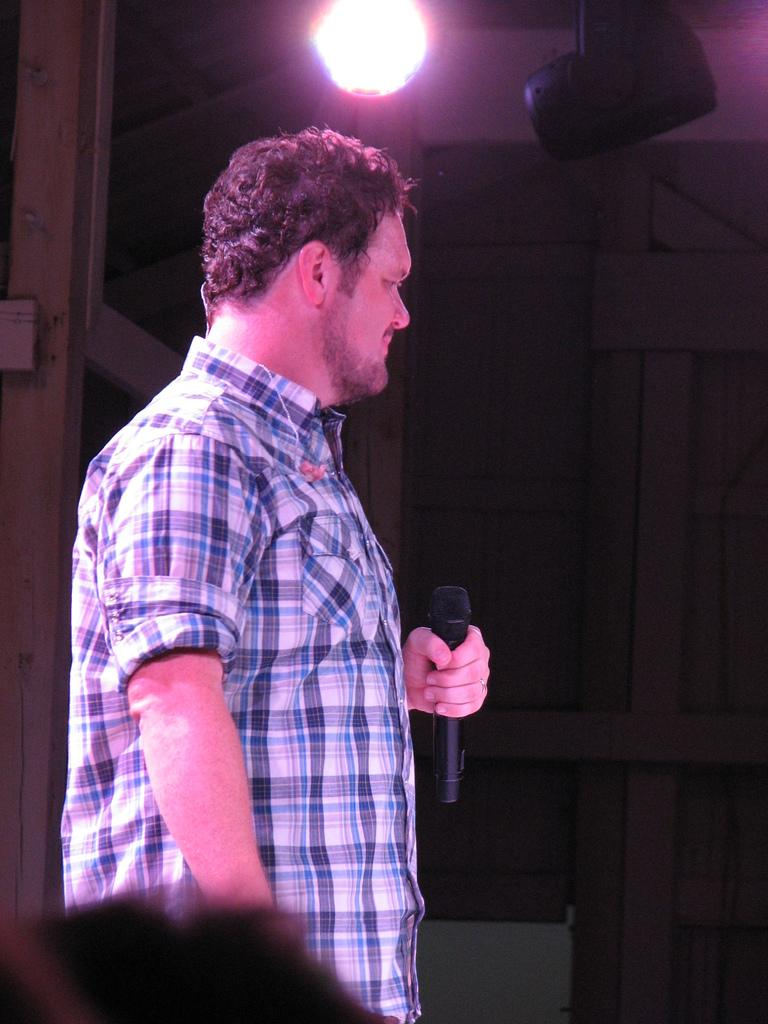What is the main subject of the image? The main subject of the image is a man. Can you describe the man's clothing in the image? The man is wearing a blue checkered shirt in the image. What is the man holding in his hands? The man is holding a microphone in his hands. What can be seen in the background of the image? There are show lights visible in the image. Can you see the man's tail in the image? There is no tail visible in the image, as the man is not an animal. What type of garden can be seen in the image? There is no garden present in the image; it features a man holding a microphone with show lights in the background. 